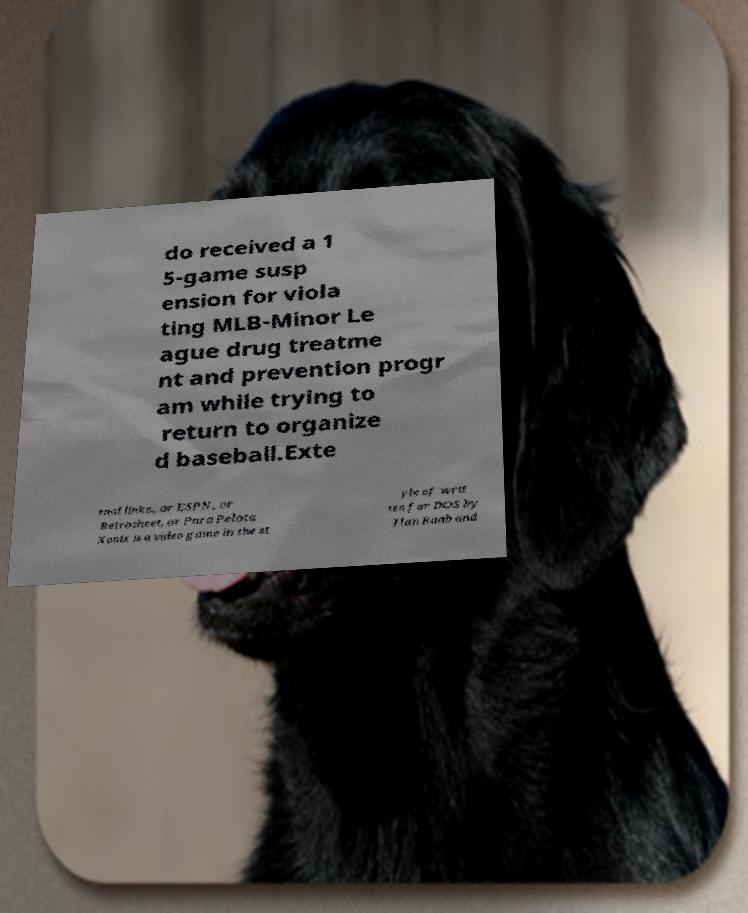What messages or text are displayed in this image? I need them in a readable, typed format. do received a 1 5-game susp ension for viola ting MLB-Minor Le ague drug treatme nt and prevention progr am while trying to return to organize d baseball.Exte rnal links., or ESPN, or Retrosheet, or Pura Pelota Xonix is a video game in the st yle of writ ten for DOS by Ilan Raab and 